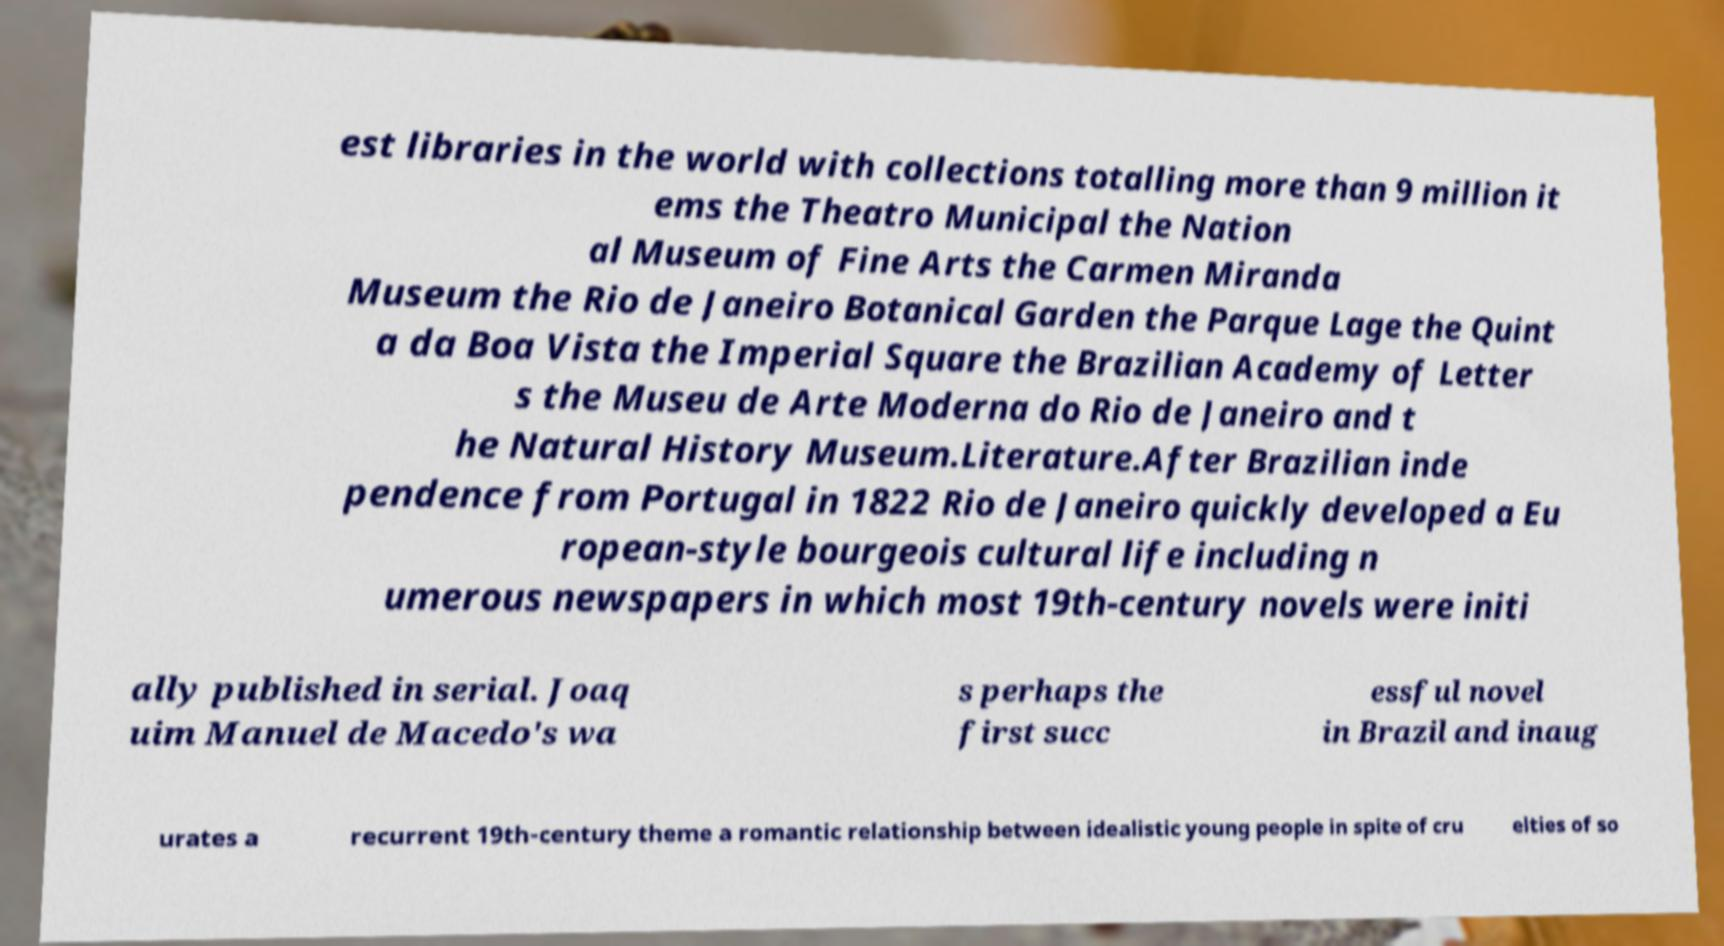Please read and relay the text visible in this image. What does it say? est libraries in the world with collections totalling more than 9 million it ems the Theatro Municipal the Nation al Museum of Fine Arts the Carmen Miranda Museum the Rio de Janeiro Botanical Garden the Parque Lage the Quint a da Boa Vista the Imperial Square the Brazilian Academy of Letter s the Museu de Arte Moderna do Rio de Janeiro and t he Natural History Museum.Literature.After Brazilian inde pendence from Portugal in 1822 Rio de Janeiro quickly developed a Eu ropean-style bourgeois cultural life including n umerous newspapers in which most 19th-century novels were initi ally published in serial. Joaq uim Manuel de Macedo's wa s perhaps the first succ essful novel in Brazil and inaug urates a recurrent 19th-century theme a romantic relationship between idealistic young people in spite of cru elties of so 